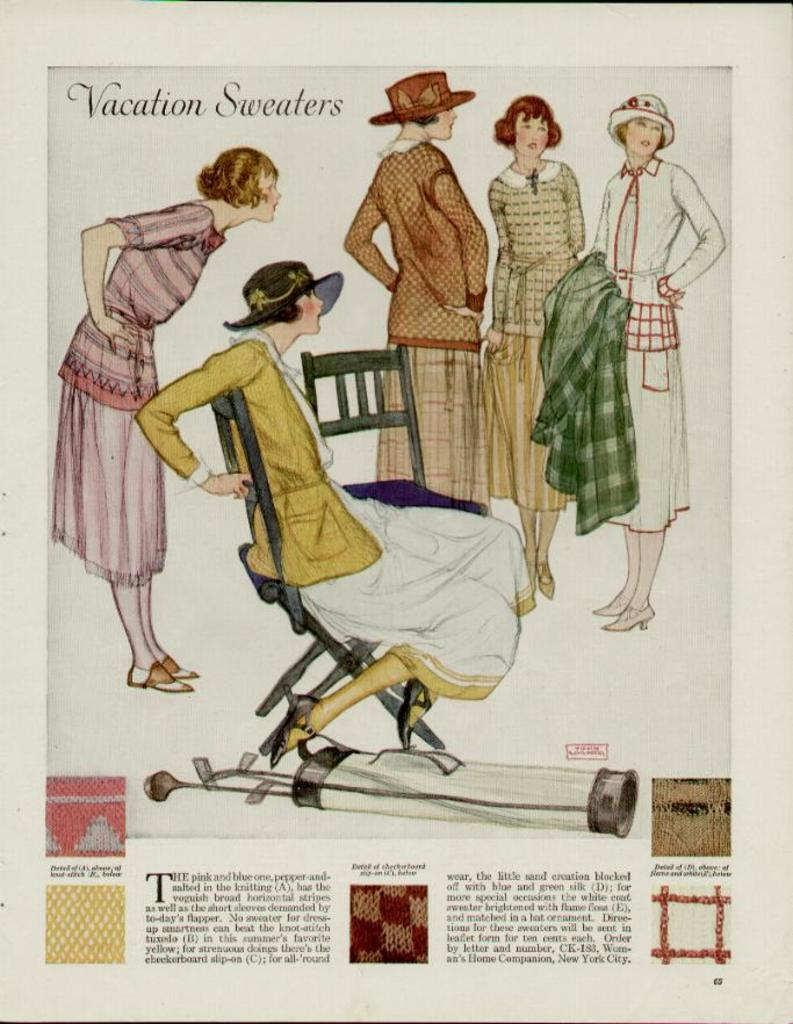What is happening in the image involving people? There are pictures of people standing in the image. What is the woman in the image doing? The woman is sitting on a chair in the image. What else can be seen in the image besides people? There is text present in the image. What type of pear is being used to trick the woman in the image? There is no pear present in the image, nor is there any indication of a trick being played on the woman. 